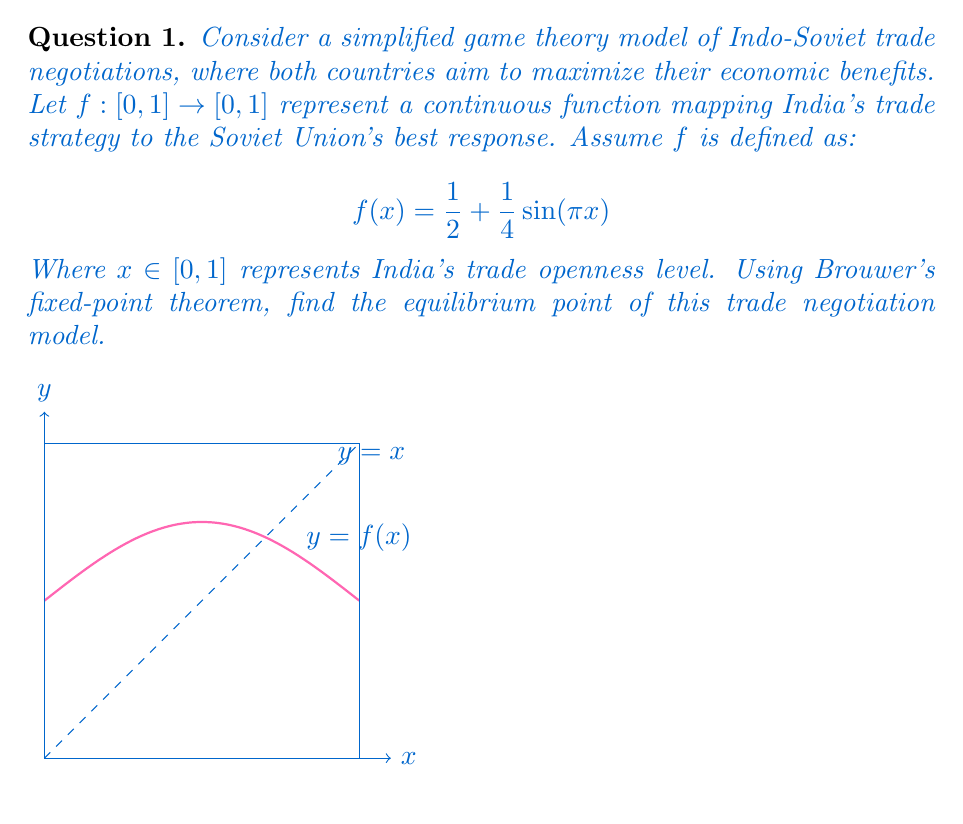Help me with this question. To solve this problem, we'll follow these steps:

1) Brouwer's fixed-point theorem states that every continuous function from a convex compact subset of a Euclidean space to itself has a fixed point. In our case, $f: [0,1] \to [0,1]$ is a continuous function on a closed interval, which satisfies the conditions of the theorem.

2) A fixed point of $f$ is a point $x^*$ such that $f(x^*) = x^*$. To find this point, we need to solve the equation:

   $$x = \frac{1}{2} + \frac{1}{4}\sin(\pi x)$$

3) Rearranging the equation:

   $$x - \frac{1}{2} = \frac{1}{4}\sin(\pi x)$$
   $$4x - 2 = \sin(\pi x)$$

4) This transcendental equation cannot be solved algebraically. However, we can observe from the graph that the function $f(x)$ intersects the line $y=x$ at a single point between 0.5 and 1.

5) We can approximate this point using numerical methods. Using a simple bisection method or Newton's method, we find that the solution is approximately:

   $$x^* \approx 0.6387$$

6) This fixed point represents the equilibrium strategy for both India and the Soviet Union in this simplified trade negotiation model. At this point, neither country has an incentive to unilaterally change their strategy.

7) In the context of Indo-Soviet relations, this equilibrium point suggests a moderate level of trade openness, balancing between protectionist policies and free trade.
Answer: $x^* \approx 0.6387$ 